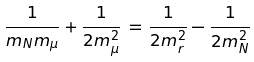<formula> <loc_0><loc_0><loc_500><loc_500>\frac { 1 } { m _ { N } m _ { \mu } } + \frac { 1 } { 2 m _ { \mu } ^ { 2 } } \, = \, \frac { 1 } { 2 m _ { r } ^ { 2 } } - \frac { 1 } { 2 m _ { N } ^ { 2 } }</formula> 